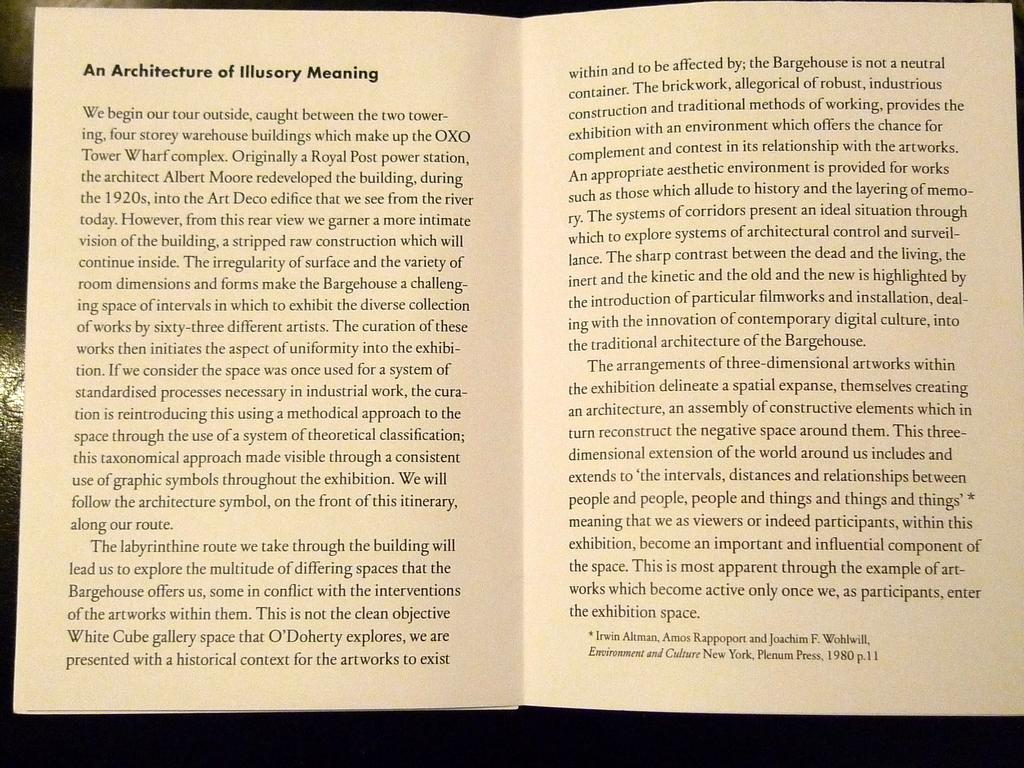<image>
Give a short and clear explanation of the subsequent image. A book is open to the section An Architecture of Illusory Meaning. 